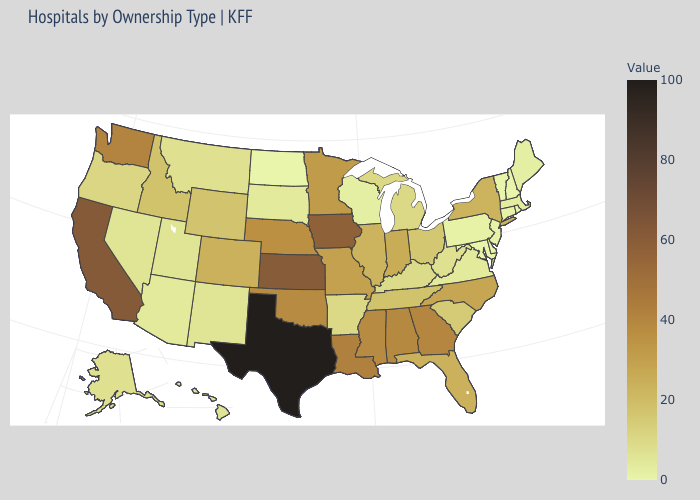Does Massachusetts have a higher value than California?
Short answer required. No. Does Texas have the highest value in the USA?
Concise answer only. Yes. Does Alaska have the lowest value in the West?
Give a very brief answer. No. Among the states that border Oklahoma , which have the lowest value?
Concise answer only. New Mexico. Which states have the lowest value in the USA?
Give a very brief answer. Delaware, Maryland, New Hampshire, North Dakota, Rhode Island, Vermont. 